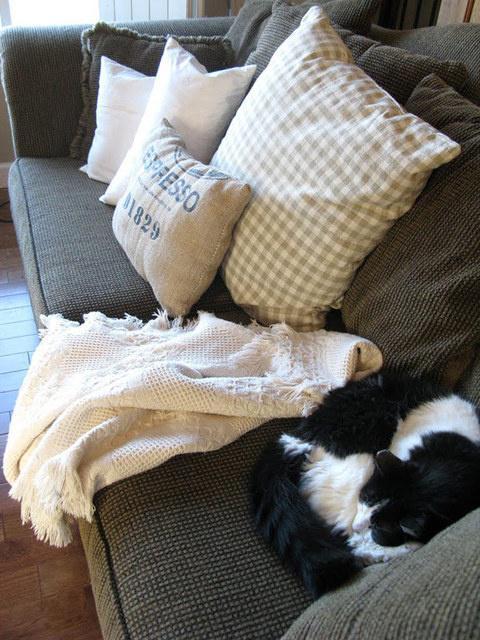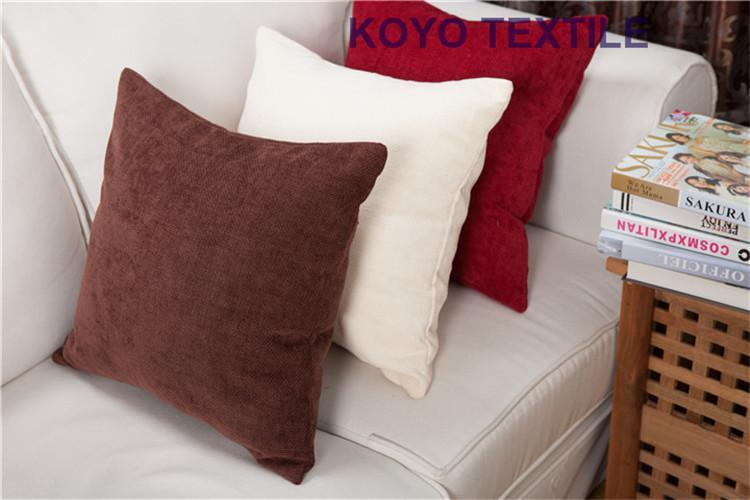The first image is the image on the left, the second image is the image on the right. Assess this claim about the two images: "An image includes at least one pillow shaped like a slice of bread.". Correct or not? Answer yes or no. No. 